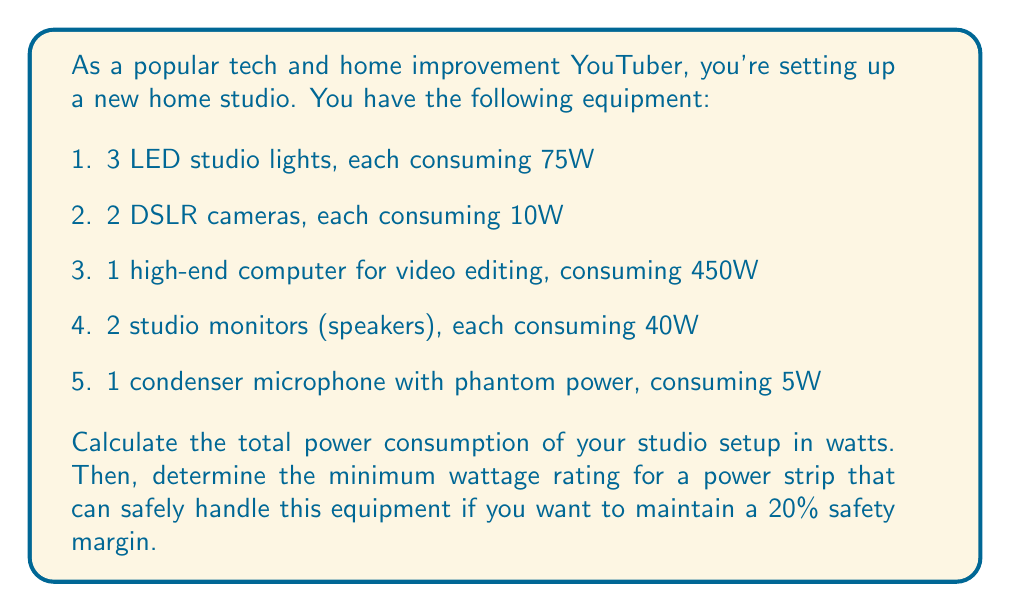Solve this math problem. To solve this problem, we'll follow these steps:

1. Calculate the total power consumption of all equipment
2. Add a 20% safety margin to determine the minimum power strip rating

Step 1: Calculate total power consumption

Let's sum up the power consumption of each piece of equipment:

$$ \begin{align}
\text{LED lights} &= 3 \times 75\text{W} = 225\text{W} \\
\text{DSLR cameras} &= 2 \times 10\text{W} = 20\text{W} \\
\text{Computer} &= 450\text{W} \\
\text{Studio monitors} &= 2 \times 40\text{W} = 80\text{W} \\
\text{Microphone} &= 5\text{W}
\end{align} $$

Total power consumption:
$$ 225\text{W} + 20\text{W} + 450\text{W} + 80\text{W} + 5\text{W} = 780\text{W} $$

Step 2: Add 20% safety margin

To calculate the minimum power strip rating with a 20% safety margin, we need to increase the total power consumption by 20%:

$$ \begin{align}
\text{Safety margin} &= 780\text{W} \times 0.20 = 156\text{W} \\
\text{Minimum rating} &= 780\text{W} + 156\text{W} = 936\text{W}
\end{align} $$

Therefore, you should choose a power strip with a rating of at least 936W.
Answer: The total power consumption of the studio setup is 780W. The minimum wattage rating for a power strip that can safely handle this equipment with a 20% safety margin is 936W. 